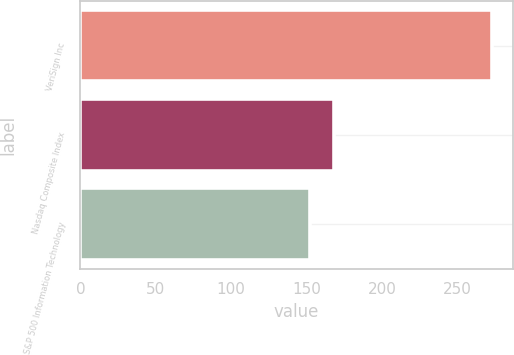Convert chart. <chart><loc_0><loc_0><loc_500><loc_500><bar_chart><fcel>VeriSign Inc<fcel>Nasdaq Composite Index<fcel>S&P 500 Information Technology<nl><fcel>273<fcel>168<fcel>152<nl></chart> 